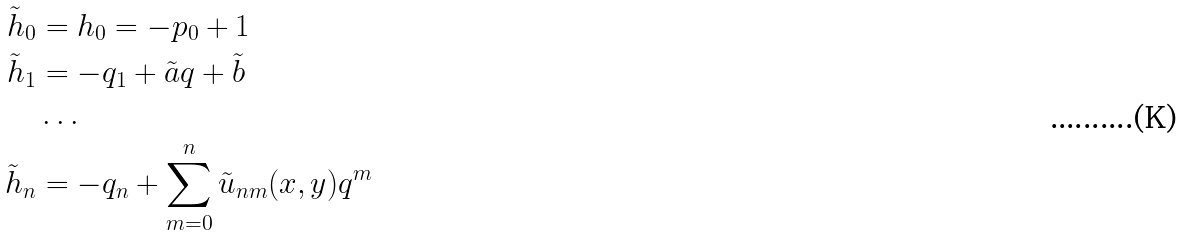Convert formula to latex. <formula><loc_0><loc_0><loc_500><loc_500>\tilde { h } _ { 0 } & = h _ { 0 } = - p _ { 0 } + 1 \\ \tilde { h } _ { 1 } & = - q _ { 1 } + \tilde { a } q + \tilde { b } \\ & \dots \\ \tilde { h } _ { n } & = - q _ { n } + \sum _ { m = 0 } ^ { n } \tilde { u } _ { n m } ( x , y ) q ^ { m }</formula> 